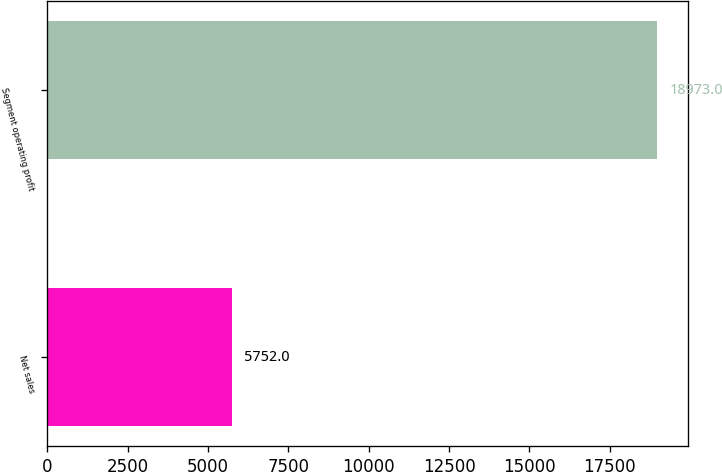<chart> <loc_0><loc_0><loc_500><loc_500><bar_chart><fcel>Net sales<fcel>Segment operating profit<nl><fcel>5752<fcel>18973<nl></chart> 